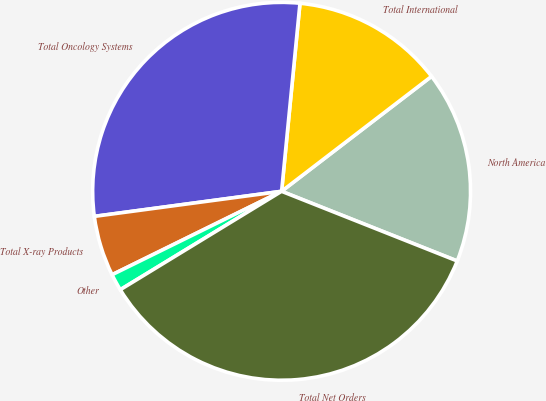<chart> <loc_0><loc_0><loc_500><loc_500><pie_chart><fcel>North America<fcel>Total International<fcel>Total Oncology Systems<fcel>Total X-ray Products<fcel>Other<fcel>Total Net Orders<nl><fcel>16.42%<fcel>13.04%<fcel>28.67%<fcel>5.16%<fcel>1.44%<fcel>35.27%<nl></chart> 